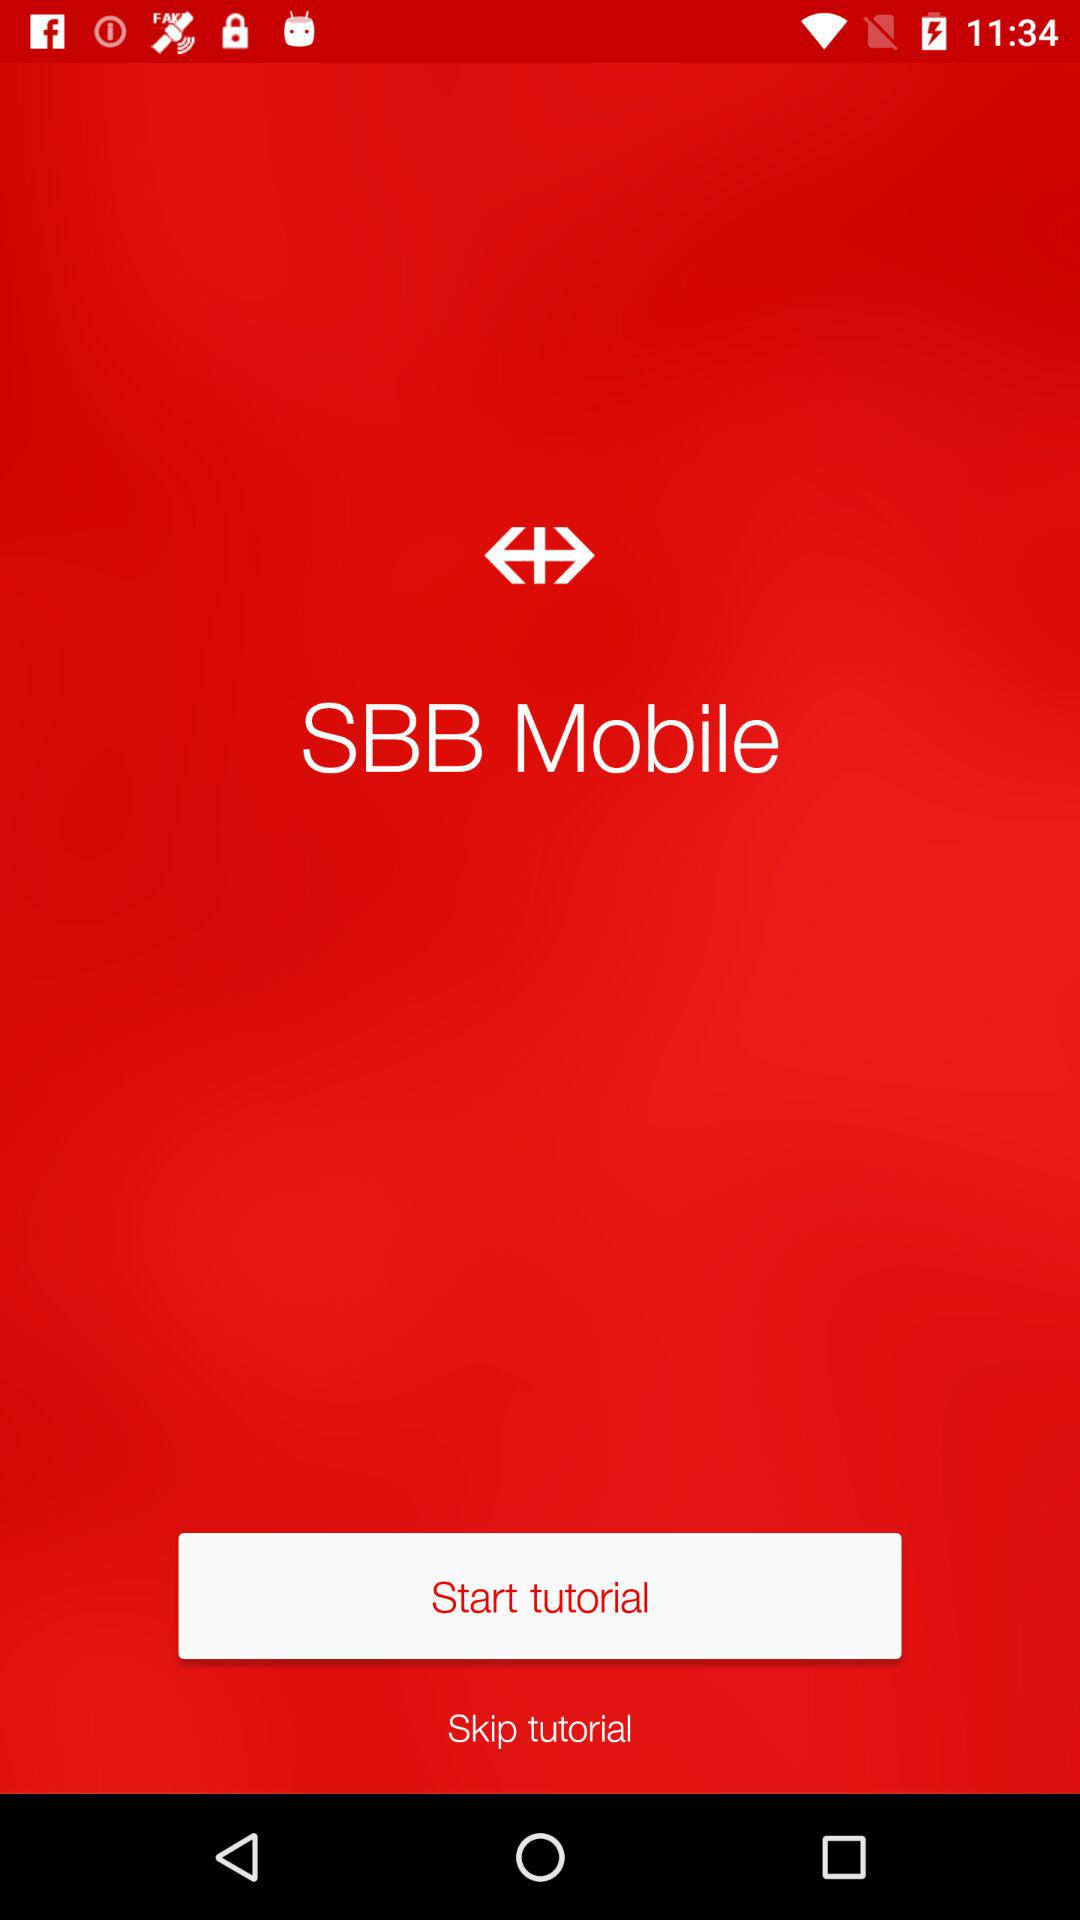Who is this application powered by?
When the provided information is insufficient, respond with <no answer>. <no answer> 